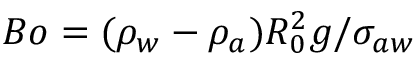Convert formula to latex. <formula><loc_0><loc_0><loc_500><loc_500>B o = ( { \rho } _ { w } - { \rho } _ { a } ) R _ { 0 } ^ { 2 } g / { \sigma } _ { a w }</formula> 